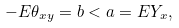Convert formula to latex. <formula><loc_0><loc_0><loc_500><loc_500>- { E } \theta _ { x y } = b < a = { E } Y _ { x } ,</formula> 